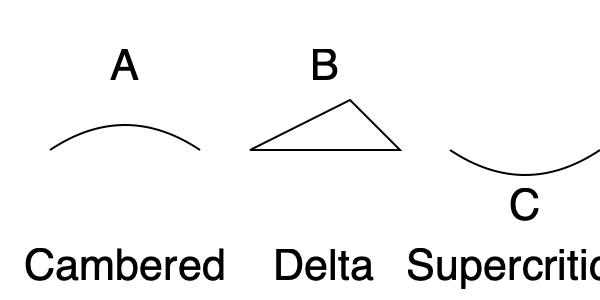Which of the wing designs shown above (A, B, or C) is most suitable for an aircraft intended to operate at transonic speeds (Mach 0.8 - 1.2) and why? To determine the most suitable wing design for transonic speeds, let's analyze each wing type:

1. Wing A (Cambered):
   - Provides good lift at low speeds
   - Efficient for subsonic flight
   - Not ideal for transonic speeds due to increased drag

2. Wing B (Delta):
   - Good for supersonic speeds
   - Provides stability at high speeds
   - Less efficient at subsonic speeds
   - Can handle transonic speeds but not optimal

3. Wing C (Supercritical):
   - Specially designed for transonic flight
   - Delays the onset of shock waves
   - Reduces drag at high subsonic speeds
   - Maintains efficiency in the Mach 0.8 - 1.2 range

The supercritical wing (C) is specifically engineered to perform well in the transonic regime. Its design features include:

- A flattened upper surface to reduce shock wave formation
- A curved lower surface to maintain lift
- A blunt leading edge to improve low-speed performance

These characteristics allow the supercritical wing to:

1. Delay the onset of shock waves, which occur when airflow over the wing reaches supersonic speeds
2. Reduce wave drag in the transonic regime
3. Maintain lift efficiency at high subsonic and low supersonic speeds

Therefore, Wing C (Supercritical) is the most suitable design for an aircraft intended to operate at transonic speeds (Mach 0.8 - 1.2).
Answer: Wing C (Supercritical) 